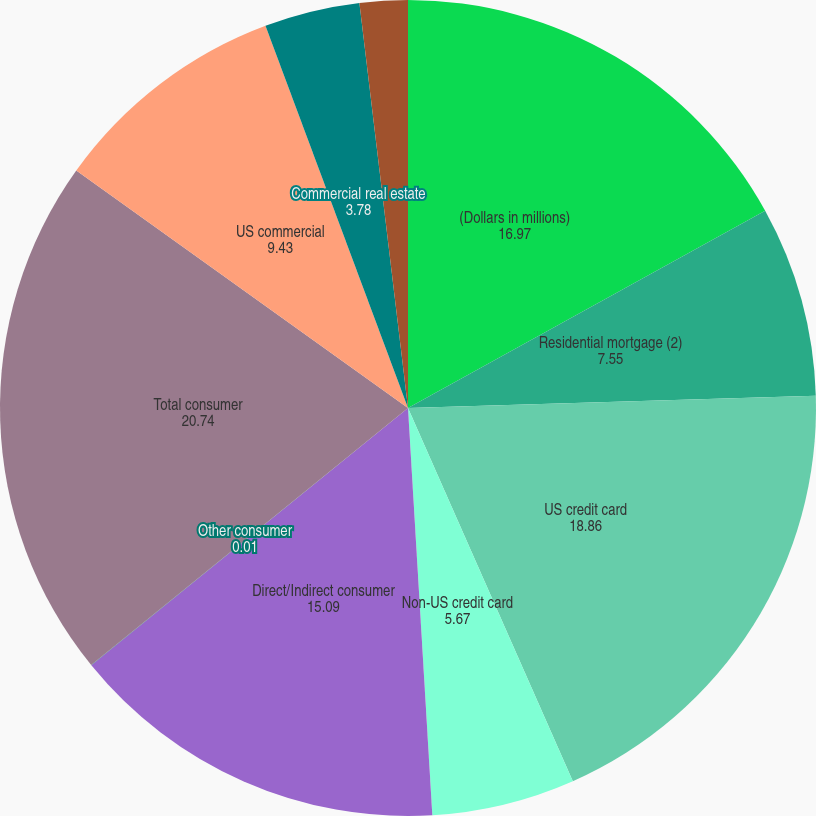Convert chart. <chart><loc_0><loc_0><loc_500><loc_500><pie_chart><fcel>(Dollars in millions)<fcel>Residential mortgage (2)<fcel>US credit card<fcel>Non-US credit card<fcel>Direct/Indirect consumer<fcel>Other consumer<fcel>Total consumer<fcel>US commercial<fcel>Commercial real estate<fcel>Commercial lease financing<nl><fcel>16.97%<fcel>7.55%<fcel>18.86%<fcel>5.67%<fcel>15.09%<fcel>0.01%<fcel>20.74%<fcel>9.43%<fcel>3.78%<fcel>1.9%<nl></chart> 